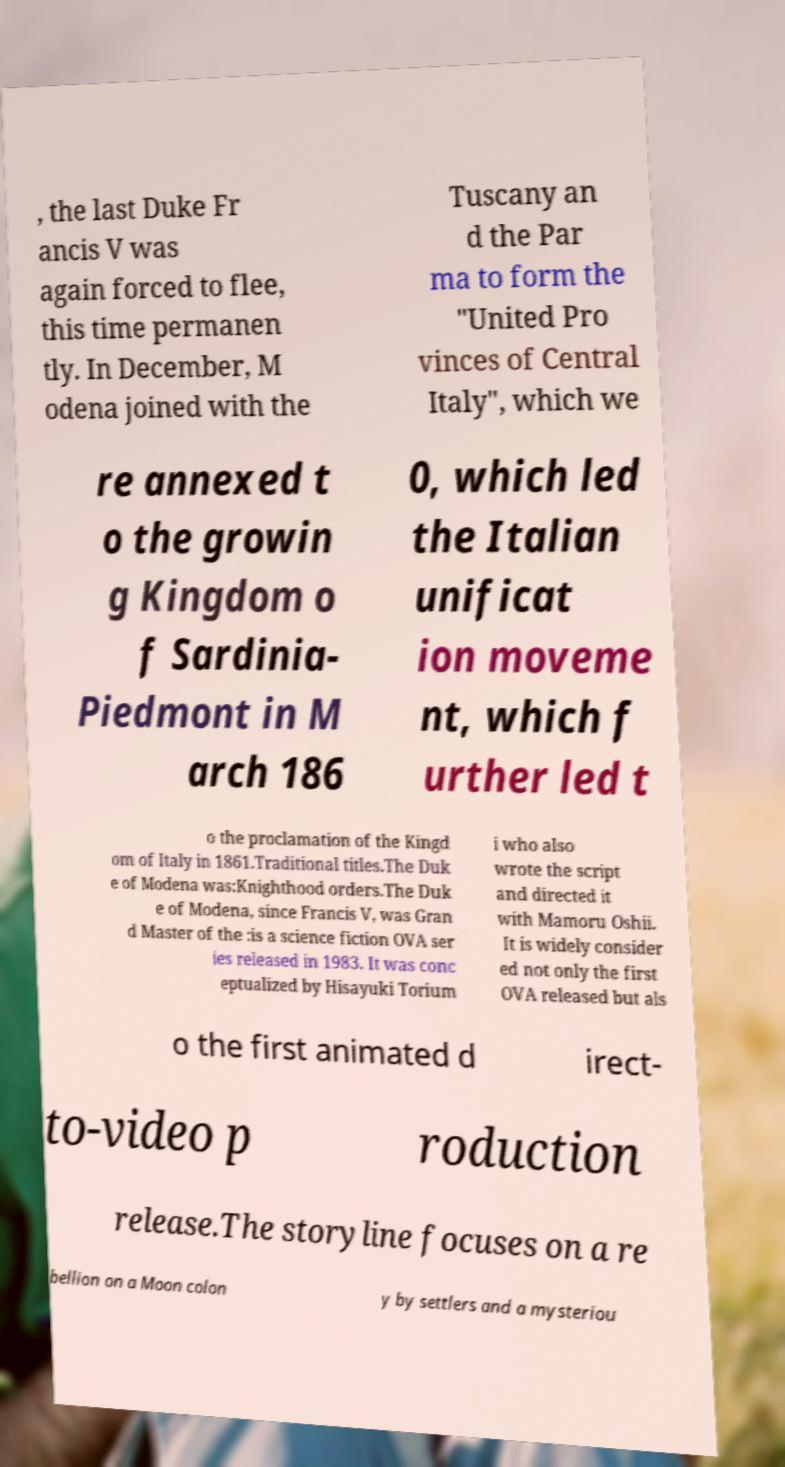Can you read and provide the text displayed in the image?This photo seems to have some interesting text. Can you extract and type it out for me? , the last Duke Fr ancis V was again forced to flee, this time permanen tly. In December, M odena joined with the Tuscany an d the Par ma to form the "United Pro vinces of Central Italy", which we re annexed t o the growin g Kingdom o f Sardinia- Piedmont in M arch 186 0, which led the Italian unificat ion moveme nt, which f urther led t o the proclamation of the Kingd om of Italy in 1861.Traditional titles.The Duk e of Modena was:Knighthood orders.The Duk e of Modena, since Francis V, was Gran d Master of the :is a science fiction OVA ser ies released in 1983. It was conc eptualized by Hisayuki Torium i who also wrote the script and directed it with Mamoru Oshii. It is widely consider ed not only the first OVA released but als o the first animated d irect- to-video p roduction release.The storyline focuses on a re bellion on a Moon colon y by settlers and a mysteriou 